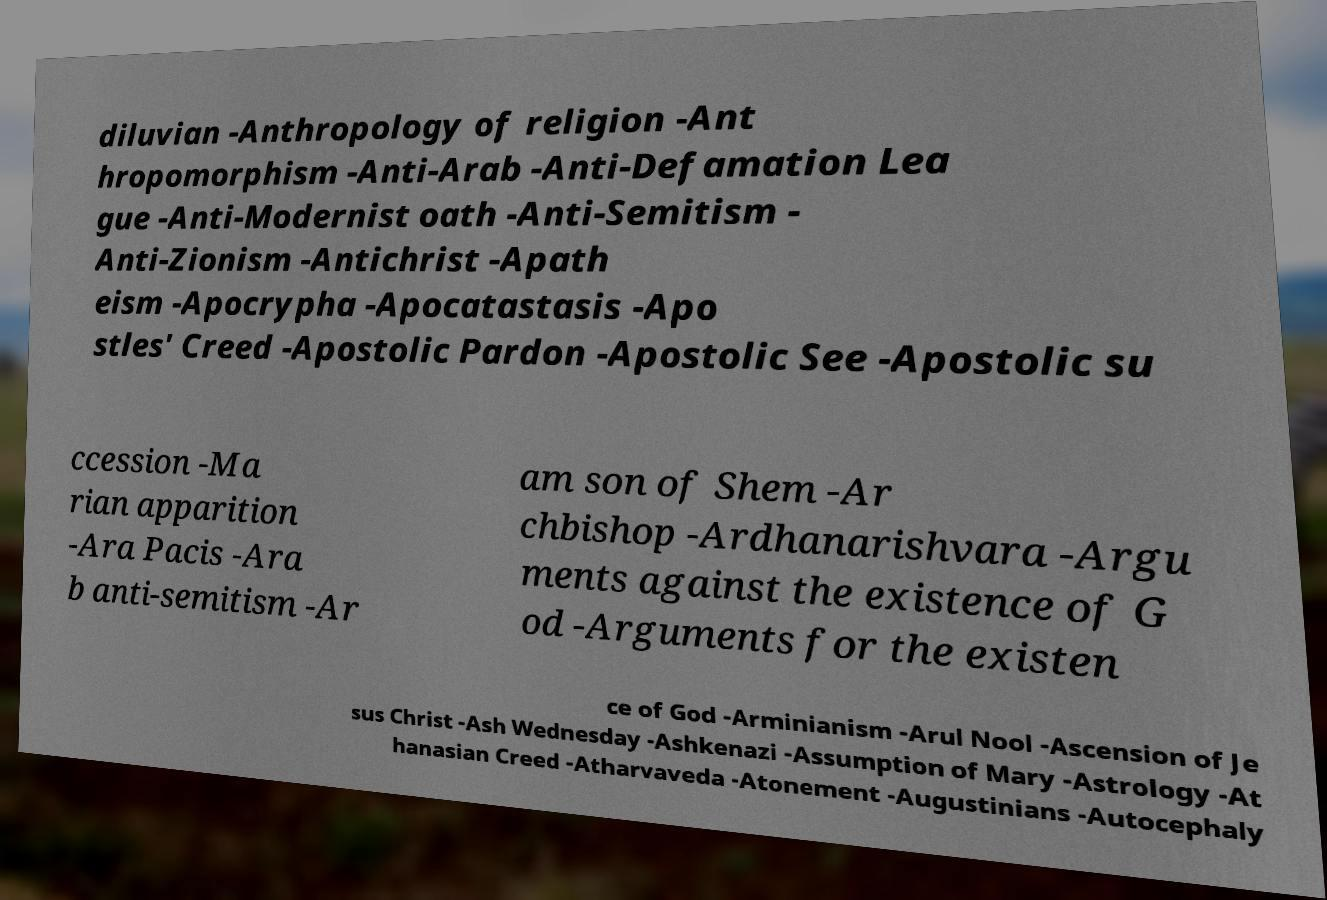There's text embedded in this image that I need extracted. Can you transcribe it verbatim? diluvian -Anthropology of religion -Ant hropomorphism -Anti-Arab -Anti-Defamation Lea gue -Anti-Modernist oath -Anti-Semitism - Anti-Zionism -Antichrist -Apath eism -Apocrypha -Apocatastasis -Apo stles' Creed -Apostolic Pardon -Apostolic See -Apostolic su ccession -Ma rian apparition -Ara Pacis -Ara b anti-semitism -Ar am son of Shem -Ar chbishop -Ardhanarishvara -Argu ments against the existence of G od -Arguments for the existen ce of God -Arminianism -Arul Nool -Ascension of Je sus Christ -Ash Wednesday -Ashkenazi -Assumption of Mary -Astrology -At hanasian Creed -Atharvaveda -Atonement -Augustinians -Autocephaly 